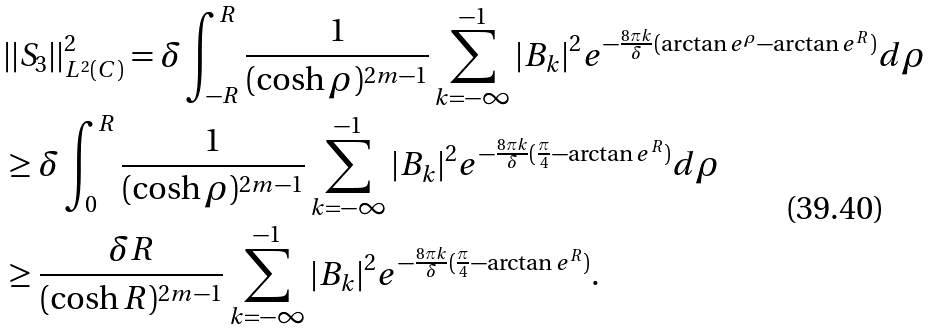Convert formula to latex. <formula><loc_0><loc_0><loc_500><loc_500>& | | S _ { 3 } | | ^ { 2 } _ { L ^ { 2 } ( C ) } = \delta \int _ { - R } ^ { R } \frac { 1 } { ( \cosh \rho ) ^ { 2 m - 1 } } \sum _ { k = - \infty } ^ { - 1 } | B _ { k } | ^ { 2 } e ^ { - \frac { 8 \pi k } { \delta } ( \arctan e ^ { \rho } - \arctan e ^ { R } ) } d \rho \\ & \geq \delta \int ^ { R } _ { 0 } \frac { 1 } { ( \cosh \rho ) ^ { 2 m - 1 } } \sum _ { k = - \infty } ^ { - 1 } | B _ { k } | ^ { 2 } e ^ { - \frac { 8 \pi k } { \delta } ( \frac { \pi } { 4 } - \arctan e ^ { R } ) } d \rho \\ & \geq \frac { \delta R } { ( \cosh R ) ^ { 2 m - 1 } } \sum _ { k = - \infty } ^ { - 1 } | B _ { k } | ^ { 2 } e ^ { - \frac { 8 \pi k } { \delta } ( \frac { \pi } { 4 } - \arctan e ^ { R } ) } .</formula> 